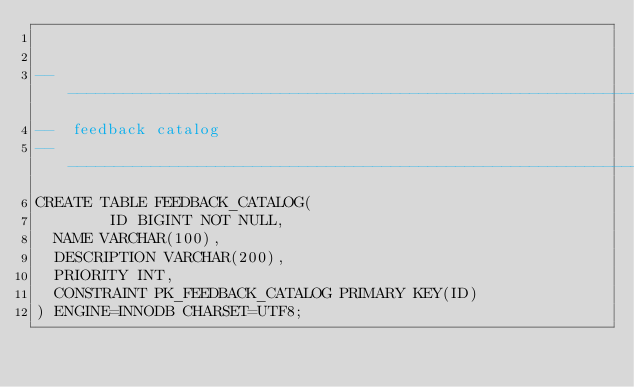<code> <loc_0><loc_0><loc_500><loc_500><_SQL_>

-------------------------------------------------------------------------------
--  feedback catalog
-------------------------------------------------------------------------------
CREATE TABLE FEEDBACK_CATALOG(
        ID BIGINT NOT NULL,
	NAME VARCHAR(100),
	DESCRIPTION VARCHAR(200),
	PRIORITY INT,
	CONSTRAINT PK_FEEDBACK_CATALOG PRIMARY KEY(ID)
) ENGINE=INNODB CHARSET=UTF8;

</code> 